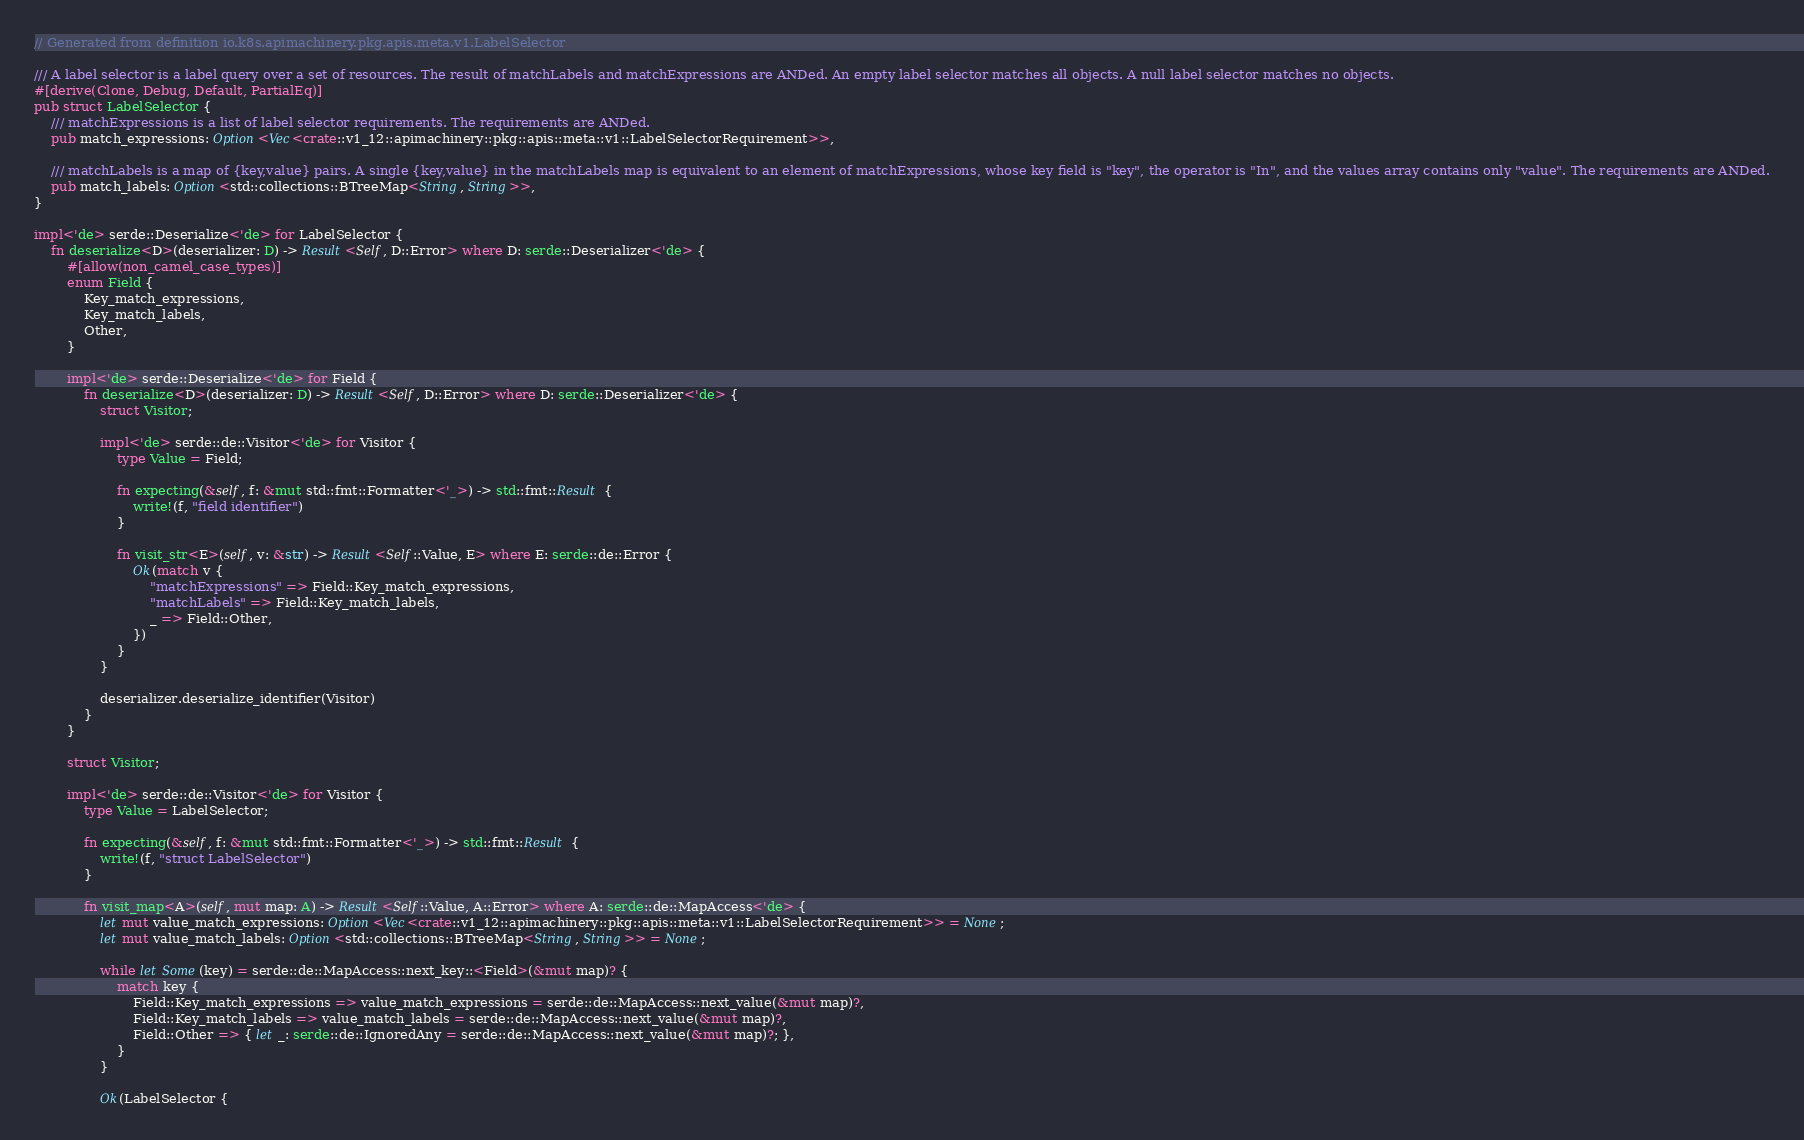<code> <loc_0><loc_0><loc_500><loc_500><_Rust_>// Generated from definition io.k8s.apimachinery.pkg.apis.meta.v1.LabelSelector

/// A label selector is a label query over a set of resources. The result of matchLabels and matchExpressions are ANDed. An empty label selector matches all objects. A null label selector matches no objects.
#[derive(Clone, Debug, Default, PartialEq)]
pub struct LabelSelector {
    /// matchExpressions is a list of label selector requirements. The requirements are ANDed.
    pub match_expressions: Option<Vec<crate::v1_12::apimachinery::pkg::apis::meta::v1::LabelSelectorRequirement>>,

    /// matchLabels is a map of {key,value} pairs. A single {key,value} in the matchLabels map is equivalent to an element of matchExpressions, whose key field is "key", the operator is "In", and the values array contains only "value". The requirements are ANDed.
    pub match_labels: Option<std::collections::BTreeMap<String, String>>,
}

impl<'de> serde::Deserialize<'de> for LabelSelector {
    fn deserialize<D>(deserializer: D) -> Result<Self, D::Error> where D: serde::Deserializer<'de> {
        #[allow(non_camel_case_types)]
        enum Field {
            Key_match_expressions,
            Key_match_labels,
            Other,
        }

        impl<'de> serde::Deserialize<'de> for Field {
            fn deserialize<D>(deserializer: D) -> Result<Self, D::Error> where D: serde::Deserializer<'de> {
                struct Visitor;

                impl<'de> serde::de::Visitor<'de> for Visitor {
                    type Value = Field;

                    fn expecting(&self, f: &mut std::fmt::Formatter<'_>) -> std::fmt::Result {
                        write!(f, "field identifier")
                    }

                    fn visit_str<E>(self, v: &str) -> Result<Self::Value, E> where E: serde::de::Error {
                        Ok(match v {
                            "matchExpressions" => Field::Key_match_expressions,
                            "matchLabels" => Field::Key_match_labels,
                            _ => Field::Other,
                        })
                    }
                }

                deserializer.deserialize_identifier(Visitor)
            }
        }

        struct Visitor;

        impl<'de> serde::de::Visitor<'de> for Visitor {
            type Value = LabelSelector;

            fn expecting(&self, f: &mut std::fmt::Formatter<'_>) -> std::fmt::Result {
                write!(f, "struct LabelSelector")
            }

            fn visit_map<A>(self, mut map: A) -> Result<Self::Value, A::Error> where A: serde::de::MapAccess<'de> {
                let mut value_match_expressions: Option<Vec<crate::v1_12::apimachinery::pkg::apis::meta::v1::LabelSelectorRequirement>> = None;
                let mut value_match_labels: Option<std::collections::BTreeMap<String, String>> = None;

                while let Some(key) = serde::de::MapAccess::next_key::<Field>(&mut map)? {
                    match key {
                        Field::Key_match_expressions => value_match_expressions = serde::de::MapAccess::next_value(&mut map)?,
                        Field::Key_match_labels => value_match_labels = serde::de::MapAccess::next_value(&mut map)?,
                        Field::Other => { let _: serde::de::IgnoredAny = serde::de::MapAccess::next_value(&mut map)?; },
                    }
                }

                Ok(LabelSelector {</code> 